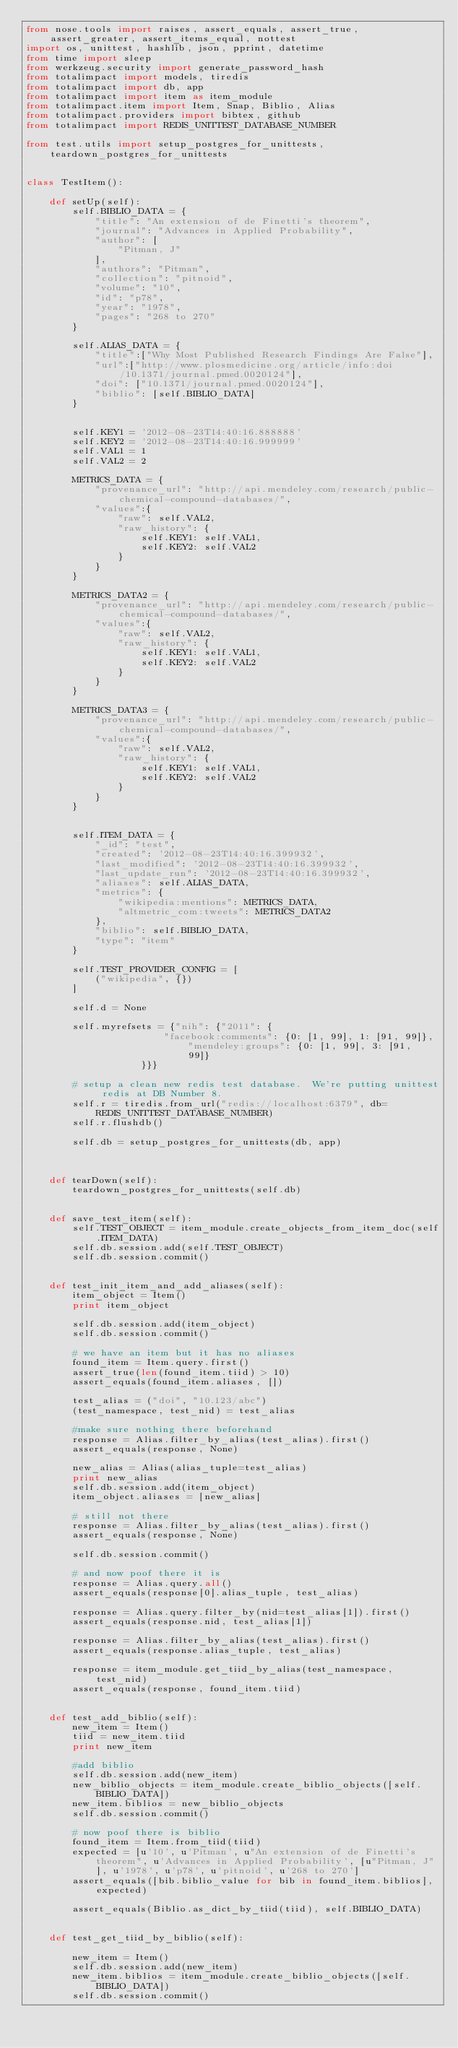Convert code to text. <code><loc_0><loc_0><loc_500><loc_500><_Python_>from nose.tools import raises, assert_equals, assert_true, assert_greater, assert_items_equal, nottest
import os, unittest, hashlib, json, pprint, datetime
from time import sleep
from werkzeug.security import generate_password_hash
from totalimpact import models, tiredis
from totalimpact import db, app
from totalimpact import item as item_module
from totalimpact.item import Item, Snap, Biblio, Alias
from totalimpact.providers import bibtex, github
from totalimpact import REDIS_UNITTEST_DATABASE_NUMBER

from test.utils import setup_postgres_for_unittests, teardown_postgres_for_unittests


class TestItem():

    def setUp(self):
        self.BIBLIO_DATA = {
            "title": "An extension of de Finetti's theorem",
            "journal": "Advances in Applied Probability",
            "author": [
                "Pitman, J"
            ],
            "authors": "Pitman",
            "collection": "pitnoid",
            "volume": "10",
            "id": "p78",
            "year": "1978",
            "pages": "268 to 270"
        }

        self.ALIAS_DATA = {
            "title":["Why Most Published Research Findings Are False"],
            "url":["http://www.plosmedicine.org/article/info:doi/10.1371/journal.pmed.0020124"],
            "doi": ["10.1371/journal.pmed.0020124"],
            "biblio": [self.BIBLIO_DATA]
        }


        self.KEY1 = '2012-08-23T14:40:16.888888'
        self.KEY2 = '2012-08-23T14:40:16.999999'
        self.VAL1 = 1
        self.VAL2 = 2

        METRICS_DATA = {
            "provenance_url": "http://api.mendeley.com/research/public-chemical-compound-databases/",
            "values":{
                "raw": self.VAL2,
                "raw_history": {
                    self.KEY1: self.VAL1,
                    self.KEY2: self.VAL2
                }
            }
        }

        METRICS_DATA2 = {
            "provenance_url": "http://api.mendeley.com/research/public-chemical-compound-databases/",
            "values":{
                "raw": self.VAL2,
                "raw_history": {
                    self.KEY1: self.VAL1,
                    self.KEY2: self.VAL2
                }
            }
        }

        METRICS_DATA3 = {
            "provenance_url": "http://api.mendeley.com/research/public-chemical-compound-databases/",
            "values":{
                "raw": self.VAL2,
                "raw_history": {
                    self.KEY1: self.VAL1,
                    self.KEY2: self.VAL2
                }
            }
        }


        self.ITEM_DATA = {
            "_id": "test",
            "created": '2012-08-23T14:40:16.399932',
            "last_modified": '2012-08-23T14:40:16.399932',
            "last_update_run": '2012-08-23T14:40:16.399932',
            "aliases": self.ALIAS_DATA,
            "metrics": {
                "wikipedia:mentions": METRICS_DATA,
                "altmetric_com:tweets": METRICS_DATA2
            },
            "biblio": self.BIBLIO_DATA,
            "type": "item"
        }

        self.TEST_PROVIDER_CONFIG = [
            ("wikipedia", {})
        ]

        self.d = None
        
        self.myrefsets = {"nih": {"2011": {
                        "facebook:comments": {0: [1, 99], 1: [91, 99]}, "mendeley:groups": {0: [1, 99], 3: [91, 99]}
                    }}}

        # setup a clean new redis test database.  We're putting unittest redis at DB Number 8.
        self.r = tiredis.from_url("redis://localhost:6379", db=REDIS_UNITTEST_DATABASE_NUMBER)
        self.r.flushdb()

        self.db = setup_postgres_for_unittests(db, app)
        


    def tearDown(self):
        teardown_postgres_for_unittests(self.db)


    def save_test_item(self):
        self.TEST_OBJECT = item_module.create_objects_from_item_doc(self.ITEM_DATA)        
        self.db.session.add(self.TEST_OBJECT)
        self.db.session.commit()


    def test_init_item_and_add_aliases(self):
        item_object = Item()
        print item_object

        self.db.session.add(item_object)
        self.db.session.commit()

        # we have an item but it has no aliases
        found_item = Item.query.first()
        assert_true(len(found_item.tiid) > 10)
        assert_equals(found_item.aliases, [])

        test_alias = ("doi", "10.123/abc")
        (test_namespace, test_nid) = test_alias

        #make sure nothing there beforehand
        response = Alias.filter_by_alias(test_alias).first()
        assert_equals(response, None)

        new_alias = Alias(alias_tuple=test_alias)
        print new_alias
        self.db.session.add(item_object)
        item_object.aliases = [new_alias]

        # still not there
        response = Alias.filter_by_alias(test_alias).first()
        assert_equals(response, None)

        self.db.session.commit()

        # and now poof there it is
        response = Alias.query.all()
        assert_equals(response[0].alias_tuple, test_alias)

        response = Alias.query.filter_by(nid=test_alias[1]).first()
        assert_equals(response.nid, test_alias[1])

        response = Alias.filter_by_alias(test_alias).first()
        assert_equals(response.alias_tuple, test_alias)

        response = item_module.get_tiid_by_alias(test_namespace, test_nid)
        assert_equals(response, found_item.tiid)


    def test_add_biblio(self):
        new_item = Item()
        tiid = new_item.tiid
        print new_item

        #add biblio
        self.db.session.add(new_item)
        new_biblio_objects = item_module.create_biblio_objects([self.BIBLIO_DATA]) 
        new_item.biblios = new_biblio_objects
        self.db.session.commit()

        # now poof there is biblio
        found_item = Item.from_tiid(tiid)
        expected = [u'10', u'Pitman', u"An extension of de Finetti's theorem", u'Advances in Applied Probability', [u"Pitman, J"], u'1978', u'p78', u'pitnoid', u'268 to 270']
        assert_equals([bib.biblio_value for bib in found_item.biblios], expected)
        
        assert_equals(Biblio.as_dict_by_tiid(tiid), self.BIBLIO_DATA)


    def test_get_tiid_by_biblio(self):

        new_item = Item()
        self.db.session.add(new_item)
        new_item.biblios = item_module.create_biblio_objects([self.BIBLIO_DATA]) 
        self.db.session.commit()
</code> 